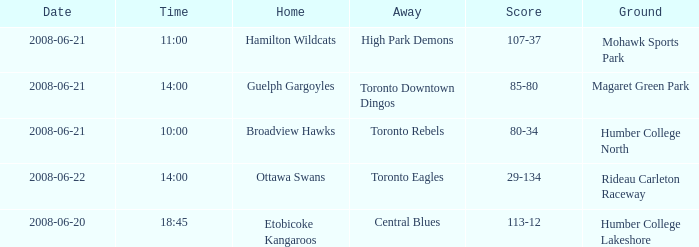What is the Away with a Ground that is humber college north? Toronto Rebels. 